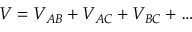<formula> <loc_0><loc_0><loc_500><loc_500>V = V _ { A B } + V _ { A C } + V _ { B C } + \dots</formula> 